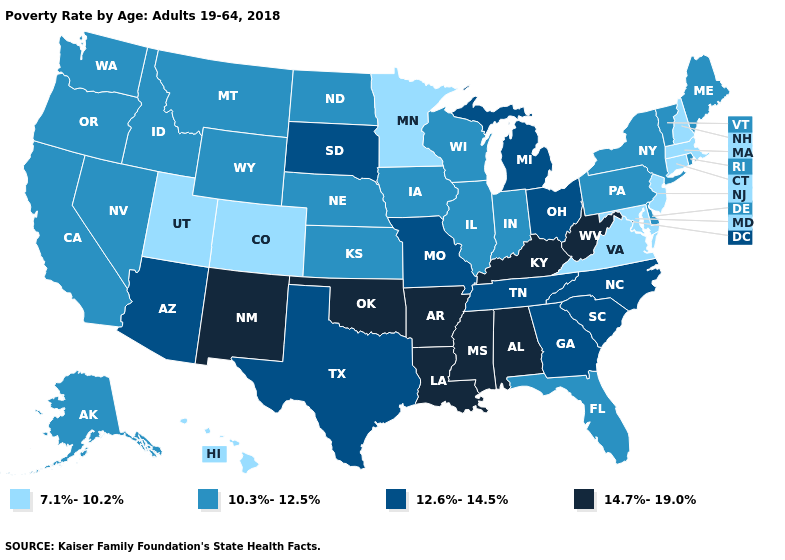How many symbols are there in the legend?
Answer briefly. 4. Which states have the lowest value in the South?
Keep it brief. Maryland, Virginia. Name the states that have a value in the range 12.6%-14.5%?
Answer briefly. Arizona, Georgia, Michigan, Missouri, North Carolina, Ohio, South Carolina, South Dakota, Tennessee, Texas. What is the value of Michigan?
Be succinct. 12.6%-14.5%. What is the lowest value in the South?
Write a very short answer. 7.1%-10.2%. Does Minnesota have the lowest value in the USA?
Be succinct. Yes. What is the highest value in the Northeast ?
Give a very brief answer. 10.3%-12.5%. Name the states that have a value in the range 7.1%-10.2%?
Be succinct. Colorado, Connecticut, Hawaii, Maryland, Massachusetts, Minnesota, New Hampshire, New Jersey, Utah, Virginia. Does Florida have a higher value than Hawaii?
Answer briefly. Yes. Is the legend a continuous bar?
Quick response, please. No. What is the value of Nevada?
Write a very short answer. 10.3%-12.5%. Name the states that have a value in the range 7.1%-10.2%?
Be succinct. Colorado, Connecticut, Hawaii, Maryland, Massachusetts, Minnesota, New Hampshire, New Jersey, Utah, Virginia. Which states have the lowest value in the South?
Give a very brief answer. Maryland, Virginia. Name the states that have a value in the range 14.7%-19.0%?
Concise answer only. Alabama, Arkansas, Kentucky, Louisiana, Mississippi, New Mexico, Oklahoma, West Virginia. Name the states that have a value in the range 12.6%-14.5%?
Short answer required. Arizona, Georgia, Michigan, Missouri, North Carolina, Ohio, South Carolina, South Dakota, Tennessee, Texas. 